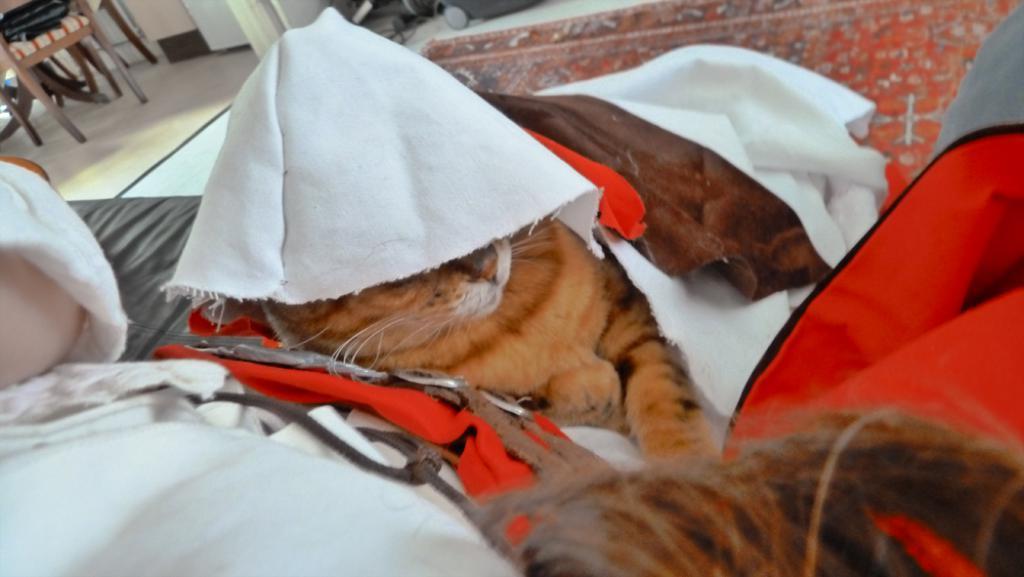Please provide a concise description of this image. In this picture we can see an animal, clothes and some objects and in the background we can see the floor, wall and some objects. 